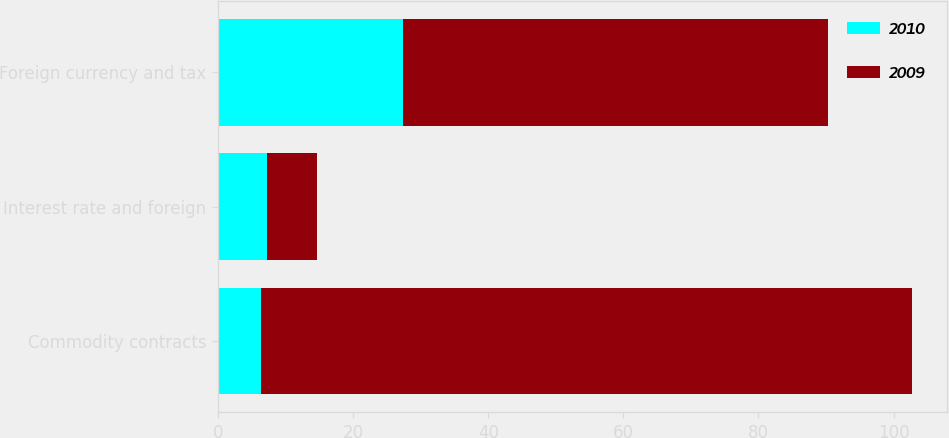Convert chart to OTSL. <chart><loc_0><loc_0><loc_500><loc_500><stacked_bar_chart><ecel><fcel>Commodity contracts<fcel>Interest rate and foreign<fcel>Foreign currency and tax<nl><fcel>2010<fcel>6.4<fcel>7.2<fcel>27.4<nl><fcel>2009<fcel>96.4<fcel>7.4<fcel>62.9<nl></chart> 